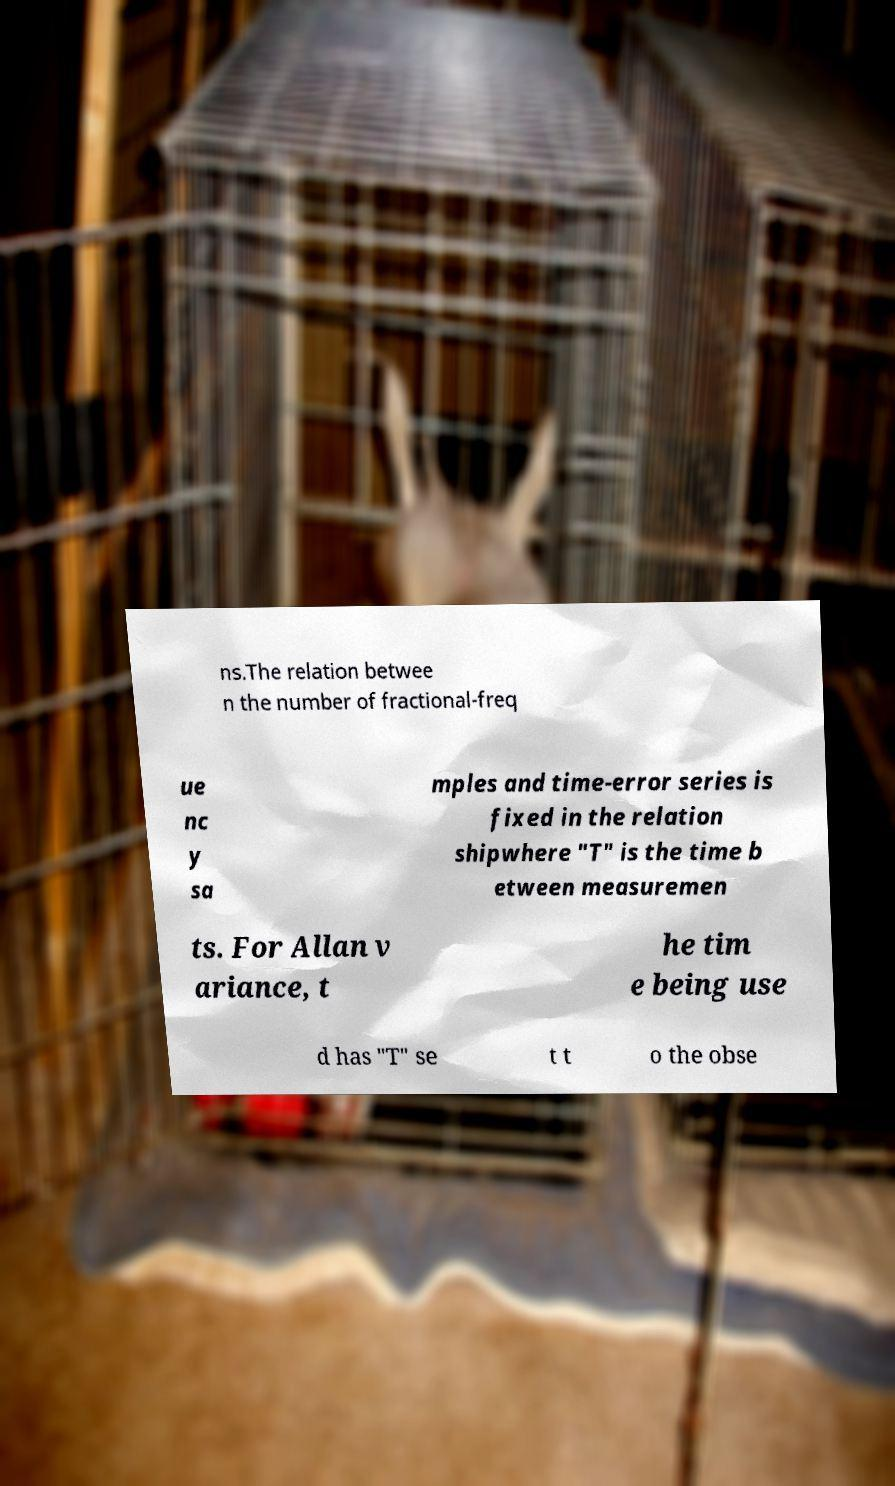There's text embedded in this image that I need extracted. Can you transcribe it verbatim? ns.The relation betwee n the number of fractional-freq ue nc y sa mples and time-error series is fixed in the relation shipwhere "T" is the time b etween measuremen ts. For Allan v ariance, t he tim e being use d has "T" se t t o the obse 